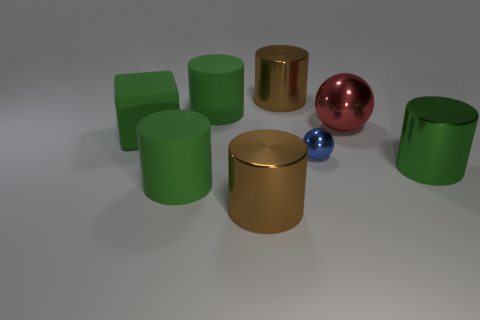Subtract all purple blocks. How many green cylinders are left? 3 Subtract all green shiny cylinders. How many cylinders are left? 4 Subtract all purple cylinders. Subtract all yellow balls. How many cylinders are left? 5 Add 2 green shiny cylinders. How many objects exist? 10 Subtract all spheres. How many objects are left? 6 Add 5 big matte things. How many big matte things exist? 8 Subtract 0 gray cylinders. How many objects are left? 8 Subtract all small cyan cylinders. Subtract all blue shiny balls. How many objects are left? 7 Add 5 blocks. How many blocks are left? 6 